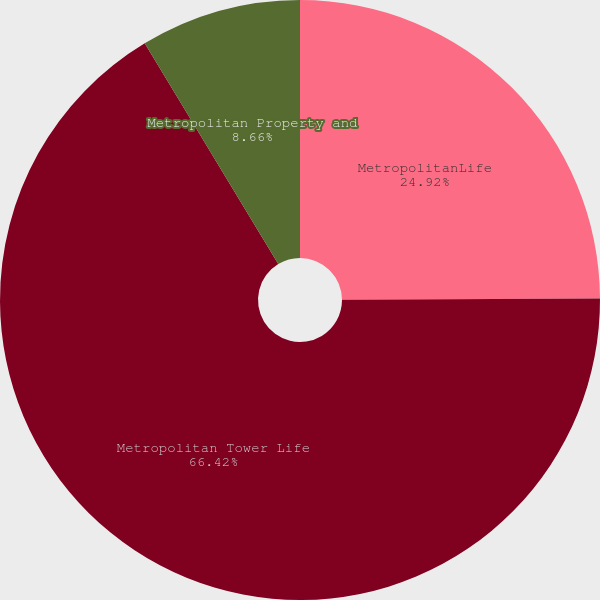Convert chart. <chart><loc_0><loc_0><loc_500><loc_500><pie_chart><fcel>MetropolitanLife<fcel>Metropolitan Tower Life<fcel>Metropolitan Property and<nl><fcel>24.92%<fcel>66.42%<fcel>8.66%<nl></chart> 